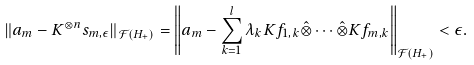<formula> <loc_0><loc_0><loc_500><loc_500>\| a _ { m } - K ^ { \otimes n } s _ { m , \epsilon } \| _ { \mathcal { F } ( H _ { + } ) } = \left \| a _ { m } - \sum _ { k = 1 } ^ { l } \lambda _ { k } K f _ { 1 , k } \hat { \otimes } \cdots \hat { \otimes } K f _ { m , k } \right \| _ { \mathcal { F } ( H _ { + } ) } < \epsilon .</formula> 